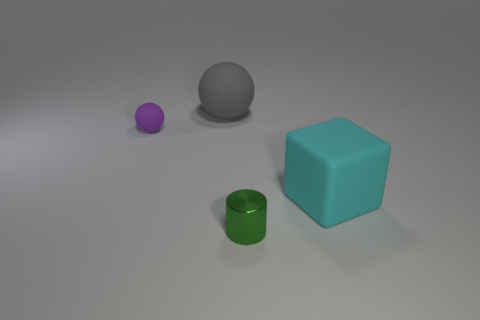Add 1 matte spheres. How many objects exist? 5 Subtract all cylinders. How many objects are left? 3 Subtract all cylinders. Subtract all tiny yellow shiny things. How many objects are left? 3 Add 1 cyan matte objects. How many cyan matte objects are left? 2 Add 4 cyan shiny balls. How many cyan shiny balls exist? 4 Subtract 0 cyan cylinders. How many objects are left? 4 